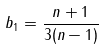<formula> <loc_0><loc_0><loc_500><loc_500>b _ { 1 } = \frac { n + 1 } { 3 ( n - 1 ) }</formula> 